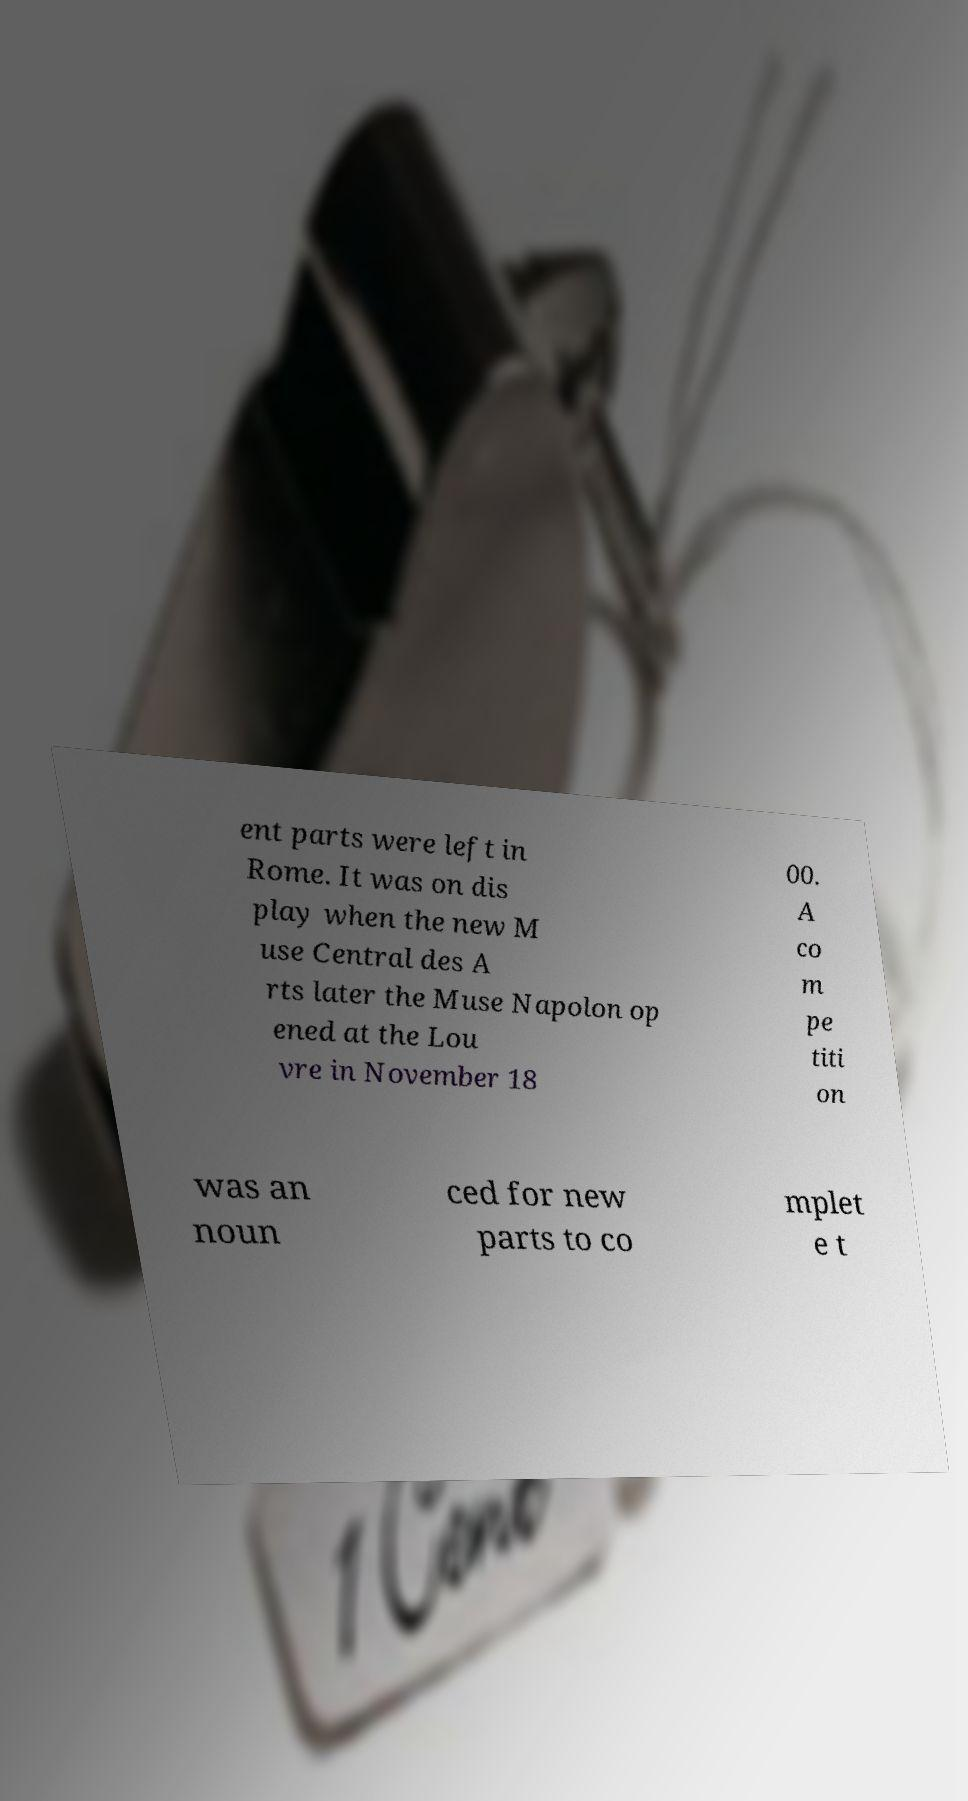Please identify and transcribe the text found in this image. ent parts were left in Rome. It was on dis play when the new M use Central des A rts later the Muse Napolon op ened at the Lou vre in November 18 00. A co m pe titi on was an noun ced for new parts to co mplet e t 